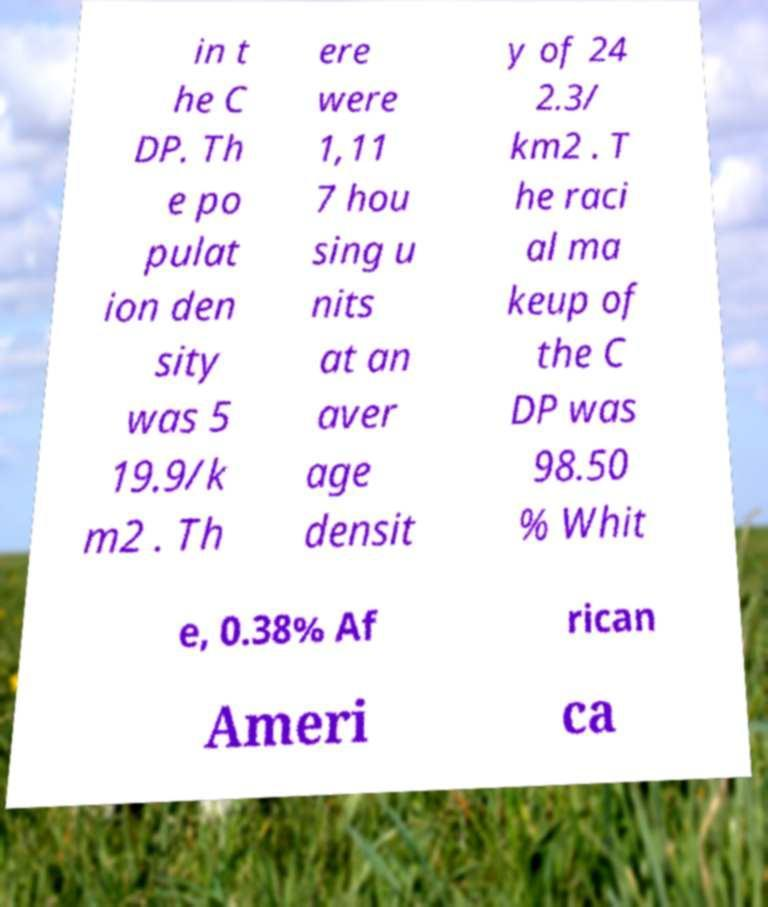I need the written content from this picture converted into text. Can you do that? in t he C DP. Th e po pulat ion den sity was 5 19.9/k m2 . Th ere were 1,11 7 hou sing u nits at an aver age densit y of 24 2.3/ km2 . T he raci al ma keup of the C DP was 98.50 % Whit e, 0.38% Af rican Ameri ca 